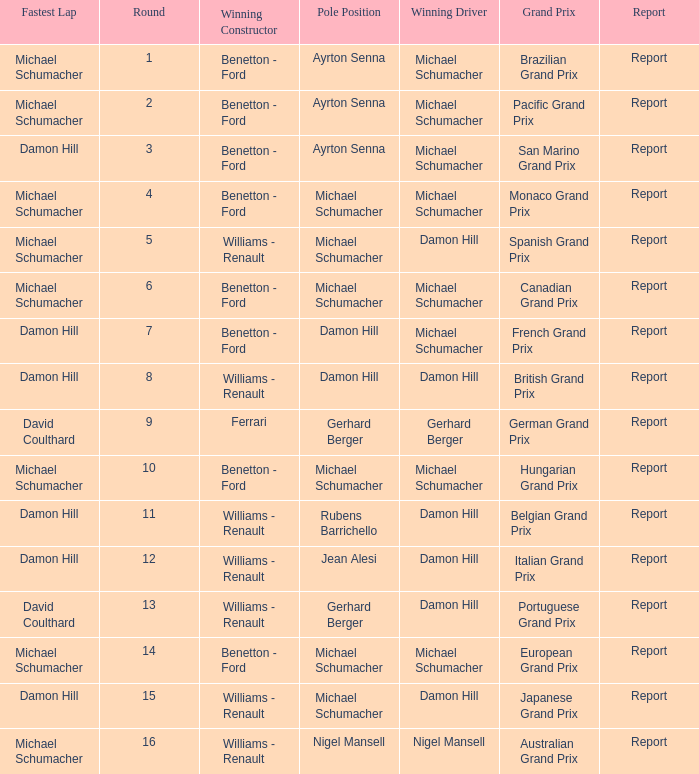Name the lowest round for when pole position and winning driver is michael schumacher 4.0. 